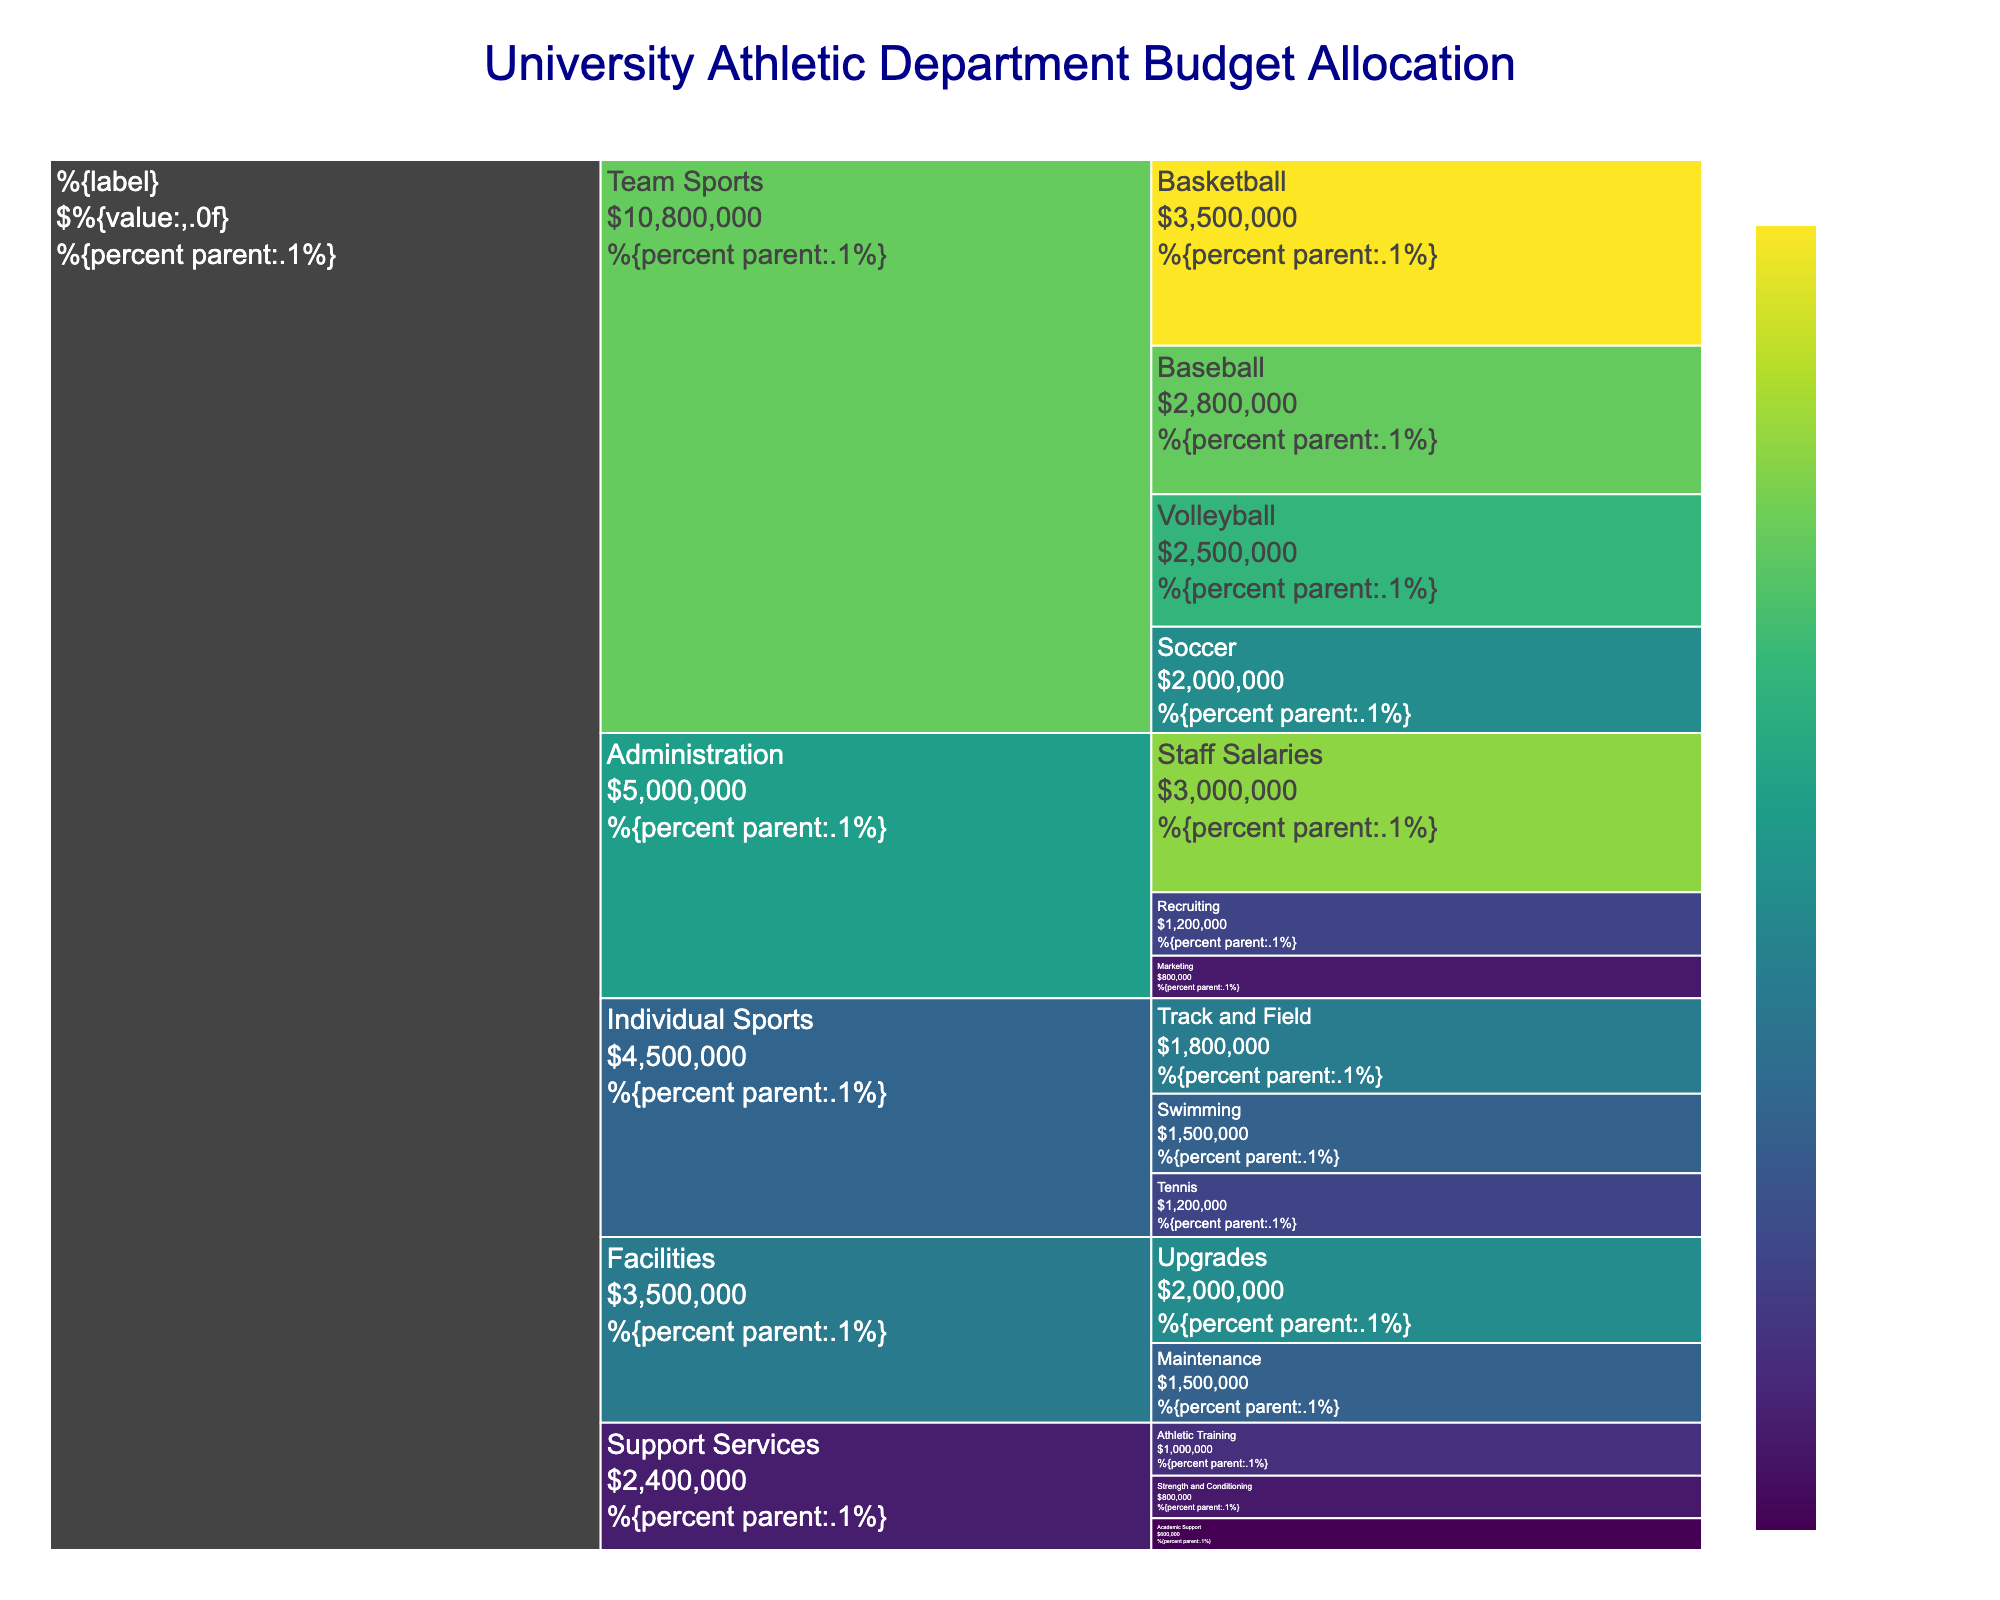What is the total budget allocated to Team Sports? The Icicle chart displays the budgets for individual sports, team sports, support services, facilities, and administration. To find the total for team sports, sum up the volleyball, basketball, soccer, and baseball values: $2,500,000 + $3,500,000 + $2,000,000 + $2,800,000 = $10,800,000.
Answer: $10,800,000 Which individual sport has the smallest budget? Referring to the section for Individual Sports in the Icicle chart, the budgets are $1,800,000 for Track and Field, $1,500,000 for Swimming, and $1,200,000 for Tennis. The smallest budget is for Tennis.
Answer: Tennis What percentage of the total budget is allocated to Administration? The total budget includes all segments: add up all given values. Administration's budget is $3,000,000 + $1,200,000 + $800,000 = $5,000,000. The sum of all budgets is $24,100,000 (adding all subcategory values). The percentage is calculated as ($5,000,000 / $24,100,000) * 100 = approximately 20.7%.
Answer: 20.7% How much more budget is allocated to Basketball compared to Soccer? The Icicle Chart's Team Sports section shows Basketball's budget is $3,500,000 and Soccer's is $2,000,000. The difference is $3,500,000 - $2,000,000 = $1,500,000.
Answer: $1,500,000 Which category has the highest total budget and how much is it? By summing the subcategories in each category: Team Sports ($10,800,000), Individual Sports ($4,500,000), Support Services ($2,400,000), Facilities ($3,500,000), Administration ($5,000,000). Team Sports has the highest budget with $10,800,000.
Answer: Team Sports, $10,800,000 Which subcategory within Support Services has the highest budget? The Support Services section shows budgets of $1,000,000 for Athletic Training, $800,000 for Strength and Conditioning, and $600,000 for Academic Support. The highest budget is for Athletic Training.
Answer: Athletic Training What is the combined budget for Facilities and Support Services? Facilities have a total budget of $1,500,000 + $2,000,000 = $3,500,000 and Support Services have $1,000,000 + $800,000 + $600,000 = $2,400,000. The combined budget is $3,500,000 + $2,400,000 = $5,900,000.
Answer: $5,900,000 How does the budget for Volleyball compare to the budget for Marketing? The Icicle chart shows Volleyball with a budget of $2,500,000 and Marketing with $800,000. Volleyball's budget is $2,500,000 - $800,000 = $1,700,000 higher.
Answer: Volleyball's budget is $1,700,000 higher What is the average budget for the categories within Administration? The Administration category includes Staff Salaries ($3,000,000), Recruiting ($1,200,000), and Marketing ($800,000). The average budget is calculated by summing these values and dividing by the count: ($3,000,000 + $1,200,000 + $800,000) / 3 = $5,000,000 / 3 = approximately $1,666,667.
Answer: Approximately $1,666,667 